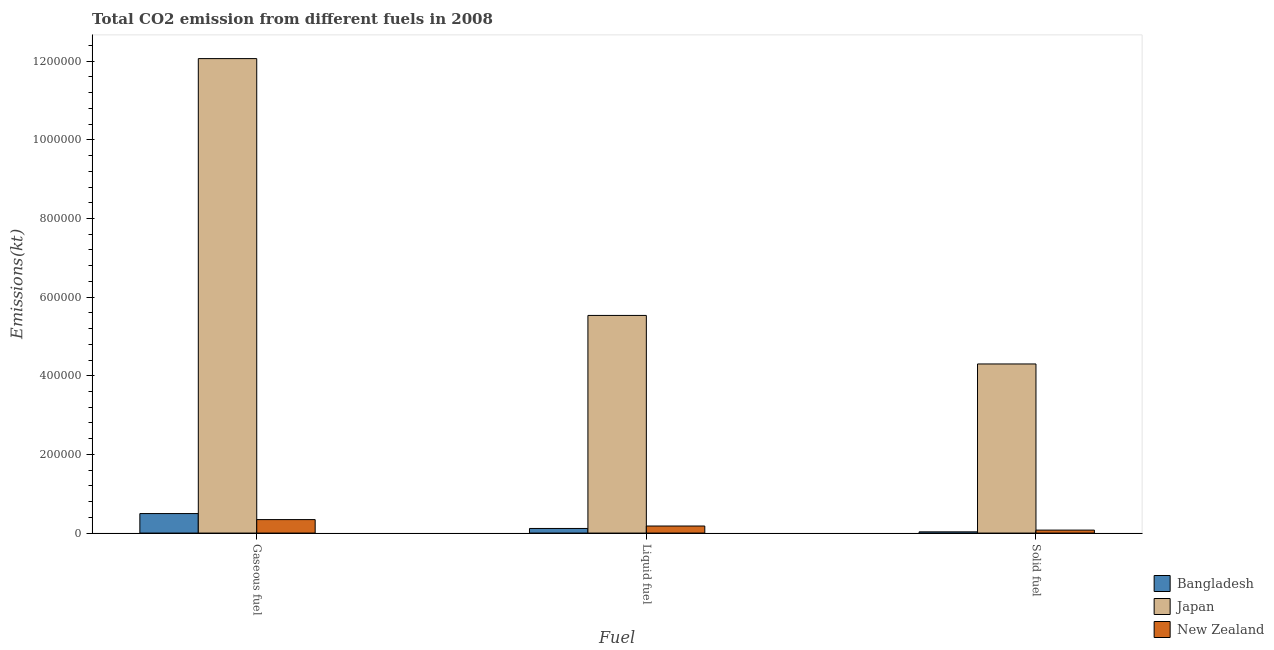How many different coloured bars are there?
Ensure brevity in your answer.  3. How many groups of bars are there?
Offer a very short reply. 3. Are the number of bars per tick equal to the number of legend labels?
Offer a very short reply. Yes. What is the label of the 1st group of bars from the left?
Your response must be concise. Gaseous fuel. What is the amount of co2 emissions from gaseous fuel in Japan?
Make the answer very short. 1.21e+06. Across all countries, what is the maximum amount of co2 emissions from liquid fuel?
Your answer should be very brief. 5.54e+05. Across all countries, what is the minimum amount of co2 emissions from solid fuel?
Offer a terse response. 3109.62. In which country was the amount of co2 emissions from solid fuel maximum?
Keep it short and to the point. Japan. In which country was the amount of co2 emissions from gaseous fuel minimum?
Ensure brevity in your answer.  New Zealand. What is the total amount of co2 emissions from solid fuel in the graph?
Ensure brevity in your answer.  4.41e+05. What is the difference between the amount of co2 emissions from liquid fuel in New Zealand and that in Bangladesh?
Offer a very short reply. 6222.9. What is the difference between the amount of co2 emissions from gaseous fuel in Japan and the amount of co2 emissions from liquid fuel in Bangladesh?
Offer a very short reply. 1.20e+06. What is the average amount of co2 emissions from solid fuel per country?
Offer a terse response. 1.47e+05. What is the difference between the amount of co2 emissions from solid fuel and amount of co2 emissions from gaseous fuel in Japan?
Your response must be concise. -7.77e+05. In how many countries, is the amount of co2 emissions from gaseous fuel greater than 440000 kt?
Your response must be concise. 1. What is the ratio of the amount of co2 emissions from gaseous fuel in Japan to that in New Zealand?
Provide a short and direct response. 35.21. Is the amount of co2 emissions from liquid fuel in New Zealand less than that in Bangladesh?
Give a very brief answer. No. Is the difference between the amount of co2 emissions from gaseous fuel in Japan and Bangladesh greater than the difference between the amount of co2 emissions from solid fuel in Japan and Bangladesh?
Your answer should be very brief. Yes. What is the difference between the highest and the second highest amount of co2 emissions from gaseous fuel?
Ensure brevity in your answer.  1.16e+06. What is the difference between the highest and the lowest amount of co2 emissions from gaseous fuel?
Give a very brief answer. 1.17e+06. Is the sum of the amount of co2 emissions from liquid fuel in New Zealand and Bangladesh greater than the maximum amount of co2 emissions from solid fuel across all countries?
Ensure brevity in your answer.  No. What does the 2nd bar from the right in Gaseous fuel represents?
Offer a very short reply. Japan. What is the difference between two consecutive major ticks on the Y-axis?
Your response must be concise. 2.00e+05. Are the values on the major ticks of Y-axis written in scientific E-notation?
Ensure brevity in your answer.  No. Does the graph contain any zero values?
Provide a succinct answer. No. Does the graph contain grids?
Offer a terse response. No. Where does the legend appear in the graph?
Keep it short and to the point. Bottom right. What is the title of the graph?
Offer a terse response. Total CO2 emission from different fuels in 2008. What is the label or title of the X-axis?
Offer a terse response. Fuel. What is the label or title of the Y-axis?
Ensure brevity in your answer.  Emissions(kt). What is the Emissions(kt) of Bangladesh in Gaseous fuel?
Make the answer very short. 4.96e+04. What is the Emissions(kt) in Japan in Gaseous fuel?
Your answer should be very brief. 1.21e+06. What is the Emissions(kt) in New Zealand in Gaseous fuel?
Offer a very short reply. 3.43e+04. What is the Emissions(kt) of Bangladesh in Liquid fuel?
Make the answer very short. 1.17e+04. What is the Emissions(kt) in Japan in Liquid fuel?
Make the answer very short. 5.54e+05. What is the Emissions(kt) in New Zealand in Liquid fuel?
Your answer should be compact. 1.79e+04. What is the Emissions(kt) in Bangladesh in Solid fuel?
Provide a succinct answer. 3109.62. What is the Emissions(kt) in Japan in Solid fuel?
Your answer should be very brief. 4.30e+05. What is the Emissions(kt) of New Zealand in Solid fuel?
Provide a short and direct response. 7561.35. Across all Fuel, what is the maximum Emissions(kt) in Bangladesh?
Ensure brevity in your answer.  4.96e+04. Across all Fuel, what is the maximum Emissions(kt) of Japan?
Your answer should be compact. 1.21e+06. Across all Fuel, what is the maximum Emissions(kt) of New Zealand?
Give a very brief answer. 3.43e+04. Across all Fuel, what is the minimum Emissions(kt) of Bangladesh?
Your response must be concise. 3109.62. Across all Fuel, what is the minimum Emissions(kt) in Japan?
Your answer should be very brief. 4.30e+05. Across all Fuel, what is the minimum Emissions(kt) in New Zealand?
Offer a terse response. 7561.35. What is the total Emissions(kt) in Bangladesh in the graph?
Provide a short and direct response. 6.44e+04. What is the total Emissions(kt) in Japan in the graph?
Offer a terse response. 2.19e+06. What is the total Emissions(kt) of New Zealand in the graph?
Ensure brevity in your answer.  5.98e+04. What is the difference between the Emissions(kt) in Bangladesh in Gaseous fuel and that in Liquid fuel?
Offer a terse response. 3.79e+04. What is the difference between the Emissions(kt) of Japan in Gaseous fuel and that in Liquid fuel?
Ensure brevity in your answer.  6.53e+05. What is the difference between the Emissions(kt) in New Zealand in Gaseous fuel and that in Liquid fuel?
Your answer should be very brief. 1.63e+04. What is the difference between the Emissions(kt) in Bangladesh in Gaseous fuel and that in Solid fuel?
Give a very brief answer. 4.65e+04. What is the difference between the Emissions(kt) of Japan in Gaseous fuel and that in Solid fuel?
Provide a succinct answer. 7.77e+05. What is the difference between the Emissions(kt) of New Zealand in Gaseous fuel and that in Solid fuel?
Provide a short and direct response. 2.67e+04. What is the difference between the Emissions(kt) in Bangladesh in Liquid fuel and that in Solid fuel?
Your response must be concise. 8606.45. What is the difference between the Emissions(kt) of Japan in Liquid fuel and that in Solid fuel?
Offer a terse response. 1.23e+05. What is the difference between the Emissions(kt) in New Zealand in Liquid fuel and that in Solid fuel?
Ensure brevity in your answer.  1.04e+04. What is the difference between the Emissions(kt) in Bangladesh in Gaseous fuel and the Emissions(kt) in Japan in Liquid fuel?
Your answer should be compact. -5.04e+05. What is the difference between the Emissions(kt) of Bangladesh in Gaseous fuel and the Emissions(kt) of New Zealand in Liquid fuel?
Offer a terse response. 3.16e+04. What is the difference between the Emissions(kt) of Japan in Gaseous fuel and the Emissions(kt) of New Zealand in Liquid fuel?
Give a very brief answer. 1.19e+06. What is the difference between the Emissions(kt) in Bangladesh in Gaseous fuel and the Emissions(kt) in Japan in Solid fuel?
Your answer should be compact. -3.81e+05. What is the difference between the Emissions(kt) of Bangladesh in Gaseous fuel and the Emissions(kt) of New Zealand in Solid fuel?
Your response must be concise. 4.20e+04. What is the difference between the Emissions(kt) in Japan in Gaseous fuel and the Emissions(kt) in New Zealand in Solid fuel?
Make the answer very short. 1.20e+06. What is the difference between the Emissions(kt) in Bangladesh in Liquid fuel and the Emissions(kt) in Japan in Solid fuel?
Make the answer very short. -4.18e+05. What is the difference between the Emissions(kt) in Bangladesh in Liquid fuel and the Emissions(kt) in New Zealand in Solid fuel?
Make the answer very short. 4154.71. What is the difference between the Emissions(kt) in Japan in Liquid fuel and the Emissions(kt) in New Zealand in Solid fuel?
Make the answer very short. 5.46e+05. What is the average Emissions(kt) in Bangladesh per Fuel?
Ensure brevity in your answer.  2.15e+04. What is the average Emissions(kt) in Japan per Fuel?
Offer a very short reply. 7.30e+05. What is the average Emissions(kt) of New Zealand per Fuel?
Your answer should be compact. 1.99e+04. What is the difference between the Emissions(kt) in Bangladesh and Emissions(kt) in Japan in Gaseous fuel?
Provide a succinct answer. -1.16e+06. What is the difference between the Emissions(kt) of Bangladesh and Emissions(kt) of New Zealand in Gaseous fuel?
Your response must be concise. 1.53e+04. What is the difference between the Emissions(kt) of Japan and Emissions(kt) of New Zealand in Gaseous fuel?
Your response must be concise. 1.17e+06. What is the difference between the Emissions(kt) of Bangladesh and Emissions(kt) of Japan in Liquid fuel?
Offer a terse response. -5.42e+05. What is the difference between the Emissions(kt) of Bangladesh and Emissions(kt) of New Zealand in Liquid fuel?
Keep it short and to the point. -6222.9. What is the difference between the Emissions(kt) in Japan and Emissions(kt) in New Zealand in Liquid fuel?
Offer a terse response. 5.36e+05. What is the difference between the Emissions(kt) in Bangladesh and Emissions(kt) in Japan in Solid fuel?
Keep it short and to the point. -4.27e+05. What is the difference between the Emissions(kt) in Bangladesh and Emissions(kt) in New Zealand in Solid fuel?
Offer a very short reply. -4451.74. What is the difference between the Emissions(kt) of Japan and Emissions(kt) of New Zealand in Solid fuel?
Give a very brief answer. 4.23e+05. What is the ratio of the Emissions(kt) of Bangladesh in Gaseous fuel to that in Liquid fuel?
Your response must be concise. 4.23. What is the ratio of the Emissions(kt) of Japan in Gaseous fuel to that in Liquid fuel?
Keep it short and to the point. 2.18. What is the ratio of the Emissions(kt) of New Zealand in Gaseous fuel to that in Liquid fuel?
Your response must be concise. 1.91. What is the ratio of the Emissions(kt) in Bangladesh in Gaseous fuel to that in Solid fuel?
Make the answer very short. 15.94. What is the ratio of the Emissions(kt) of Japan in Gaseous fuel to that in Solid fuel?
Offer a terse response. 2.81. What is the ratio of the Emissions(kt) in New Zealand in Gaseous fuel to that in Solid fuel?
Ensure brevity in your answer.  4.53. What is the ratio of the Emissions(kt) of Bangladesh in Liquid fuel to that in Solid fuel?
Ensure brevity in your answer.  3.77. What is the ratio of the Emissions(kt) of Japan in Liquid fuel to that in Solid fuel?
Provide a short and direct response. 1.29. What is the ratio of the Emissions(kt) in New Zealand in Liquid fuel to that in Solid fuel?
Offer a terse response. 2.37. What is the difference between the highest and the second highest Emissions(kt) in Bangladesh?
Provide a succinct answer. 3.79e+04. What is the difference between the highest and the second highest Emissions(kt) in Japan?
Make the answer very short. 6.53e+05. What is the difference between the highest and the second highest Emissions(kt) of New Zealand?
Your response must be concise. 1.63e+04. What is the difference between the highest and the lowest Emissions(kt) of Bangladesh?
Give a very brief answer. 4.65e+04. What is the difference between the highest and the lowest Emissions(kt) in Japan?
Give a very brief answer. 7.77e+05. What is the difference between the highest and the lowest Emissions(kt) of New Zealand?
Provide a succinct answer. 2.67e+04. 